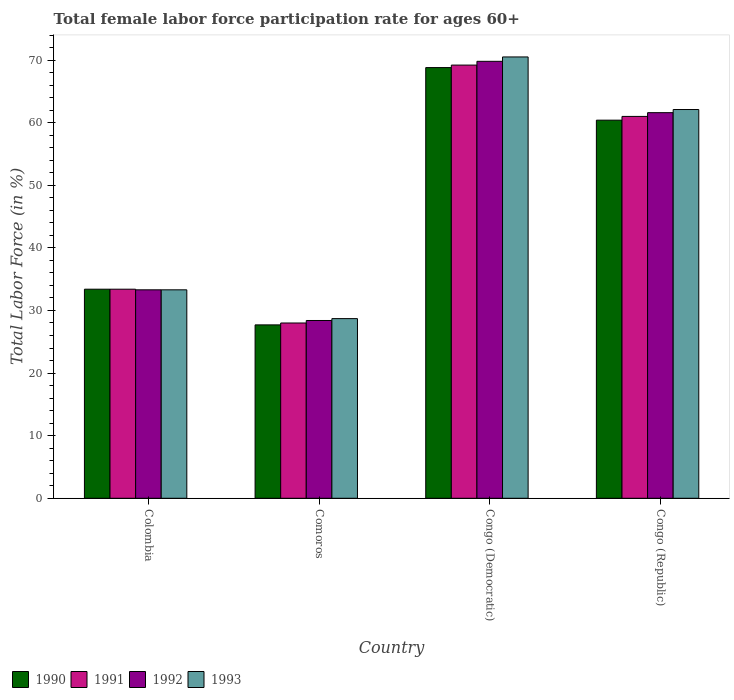Are the number of bars on each tick of the X-axis equal?
Give a very brief answer. Yes. How many bars are there on the 2nd tick from the left?
Provide a short and direct response. 4. What is the label of the 3rd group of bars from the left?
Make the answer very short. Congo (Democratic). In how many cases, is the number of bars for a given country not equal to the number of legend labels?
Your response must be concise. 0. What is the female labor force participation rate in 1990 in Congo (Democratic)?
Offer a terse response. 68.8. Across all countries, what is the maximum female labor force participation rate in 1993?
Give a very brief answer. 70.5. Across all countries, what is the minimum female labor force participation rate in 1993?
Your answer should be very brief. 28.7. In which country was the female labor force participation rate in 1992 maximum?
Your response must be concise. Congo (Democratic). In which country was the female labor force participation rate in 1990 minimum?
Your answer should be very brief. Comoros. What is the total female labor force participation rate in 1992 in the graph?
Provide a short and direct response. 193.1. What is the difference between the female labor force participation rate in 1992 in Colombia and that in Congo (Republic)?
Offer a terse response. -28.3. What is the difference between the female labor force participation rate in 1990 in Comoros and the female labor force participation rate in 1992 in Congo (Republic)?
Your answer should be very brief. -33.9. What is the average female labor force participation rate in 1990 per country?
Your response must be concise. 47.58. What is the difference between the female labor force participation rate of/in 1993 and female labor force participation rate of/in 1991 in Colombia?
Keep it short and to the point. -0.1. What is the ratio of the female labor force participation rate in 1993 in Comoros to that in Congo (Republic)?
Your answer should be compact. 0.46. What is the difference between the highest and the second highest female labor force participation rate in 1993?
Keep it short and to the point. 28.8. What is the difference between the highest and the lowest female labor force participation rate in 1993?
Provide a short and direct response. 41.8. Is the sum of the female labor force participation rate in 1991 in Colombia and Congo (Republic) greater than the maximum female labor force participation rate in 1993 across all countries?
Keep it short and to the point. Yes. Is it the case that in every country, the sum of the female labor force participation rate in 1992 and female labor force participation rate in 1991 is greater than the sum of female labor force participation rate in 1993 and female labor force participation rate in 1990?
Your response must be concise. No. What does the 4th bar from the left in Congo (Republic) represents?
Offer a terse response. 1993. What is the difference between two consecutive major ticks on the Y-axis?
Your response must be concise. 10. Does the graph contain any zero values?
Give a very brief answer. No. Does the graph contain grids?
Your response must be concise. No. Where does the legend appear in the graph?
Your answer should be very brief. Bottom left. How are the legend labels stacked?
Ensure brevity in your answer.  Horizontal. What is the title of the graph?
Offer a very short reply. Total female labor force participation rate for ages 60+. Does "1978" appear as one of the legend labels in the graph?
Provide a succinct answer. No. What is the label or title of the Y-axis?
Ensure brevity in your answer.  Total Labor Force (in %). What is the Total Labor Force (in %) of 1990 in Colombia?
Ensure brevity in your answer.  33.4. What is the Total Labor Force (in %) in 1991 in Colombia?
Give a very brief answer. 33.4. What is the Total Labor Force (in %) in 1992 in Colombia?
Provide a short and direct response. 33.3. What is the Total Labor Force (in %) in 1993 in Colombia?
Keep it short and to the point. 33.3. What is the Total Labor Force (in %) of 1990 in Comoros?
Your answer should be very brief. 27.7. What is the Total Labor Force (in %) in 1992 in Comoros?
Offer a very short reply. 28.4. What is the Total Labor Force (in %) of 1993 in Comoros?
Your answer should be compact. 28.7. What is the Total Labor Force (in %) of 1990 in Congo (Democratic)?
Your answer should be compact. 68.8. What is the Total Labor Force (in %) of 1991 in Congo (Democratic)?
Your answer should be compact. 69.2. What is the Total Labor Force (in %) in 1992 in Congo (Democratic)?
Make the answer very short. 69.8. What is the Total Labor Force (in %) in 1993 in Congo (Democratic)?
Provide a succinct answer. 70.5. What is the Total Labor Force (in %) of 1990 in Congo (Republic)?
Provide a short and direct response. 60.4. What is the Total Labor Force (in %) in 1991 in Congo (Republic)?
Your answer should be very brief. 61. What is the Total Labor Force (in %) in 1992 in Congo (Republic)?
Offer a terse response. 61.6. What is the Total Labor Force (in %) of 1993 in Congo (Republic)?
Provide a succinct answer. 62.1. Across all countries, what is the maximum Total Labor Force (in %) of 1990?
Provide a succinct answer. 68.8. Across all countries, what is the maximum Total Labor Force (in %) of 1991?
Ensure brevity in your answer.  69.2. Across all countries, what is the maximum Total Labor Force (in %) of 1992?
Provide a short and direct response. 69.8. Across all countries, what is the maximum Total Labor Force (in %) in 1993?
Offer a terse response. 70.5. Across all countries, what is the minimum Total Labor Force (in %) of 1990?
Keep it short and to the point. 27.7. Across all countries, what is the minimum Total Labor Force (in %) of 1991?
Keep it short and to the point. 28. Across all countries, what is the minimum Total Labor Force (in %) of 1992?
Your answer should be very brief. 28.4. Across all countries, what is the minimum Total Labor Force (in %) in 1993?
Make the answer very short. 28.7. What is the total Total Labor Force (in %) of 1990 in the graph?
Provide a succinct answer. 190.3. What is the total Total Labor Force (in %) of 1991 in the graph?
Your answer should be very brief. 191.6. What is the total Total Labor Force (in %) of 1992 in the graph?
Your response must be concise. 193.1. What is the total Total Labor Force (in %) in 1993 in the graph?
Ensure brevity in your answer.  194.6. What is the difference between the Total Labor Force (in %) in 1990 in Colombia and that in Congo (Democratic)?
Provide a succinct answer. -35.4. What is the difference between the Total Labor Force (in %) of 1991 in Colombia and that in Congo (Democratic)?
Provide a succinct answer. -35.8. What is the difference between the Total Labor Force (in %) of 1992 in Colombia and that in Congo (Democratic)?
Your answer should be very brief. -36.5. What is the difference between the Total Labor Force (in %) of 1993 in Colombia and that in Congo (Democratic)?
Your answer should be compact. -37.2. What is the difference between the Total Labor Force (in %) in 1991 in Colombia and that in Congo (Republic)?
Ensure brevity in your answer.  -27.6. What is the difference between the Total Labor Force (in %) of 1992 in Colombia and that in Congo (Republic)?
Offer a terse response. -28.3. What is the difference between the Total Labor Force (in %) in 1993 in Colombia and that in Congo (Republic)?
Give a very brief answer. -28.8. What is the difference between the Total Labor Force (in %) of 1990 in Comoros and that in Congo (Democratic)?
Give a very brief answer. -41.1. What is the difference between the Total Labor Force (in %) of 1991 in Comoros and that in Congo (Democratic)?
Your answer should be very brief. -41.2. What is the difference between the Total Labor Force (in %) of 1992 in Comoros and that in Congo (Democratic)?
Your answer should be very brief. -41.4. What is the difference between the Total Labor Force (in %) of 1993 in Comoros and that in Congo (Democratic)?
Give a very brief answer. -41.8. What is the difference between the Total Labor Force (in %) in 1990 in Comoros and that in Congo (Republic)?
Provide a short and direct response. -32.7. What is the difference between the Total Labor Force (in %) of 1991 in Comoros and that in Congo (Republic)?
Ensure brevity in your answer.  -33. What is the difference between the Total Labor Force (in %) in 1992 in Comoros and that in Congo (Republic)?
Make the answer very short. -33.2. What is the difference between the Total Labor Force (in %) in 1993 in Comoros and that in Congo (Republic)?
Your answer should be compact. -33.4. What is the difference between the Total Labor Force (in %) of 1990 in Congo (Democratic) and that in Congo (Republic)?
Give a very brief answer. 8.4. What is the difference between the Total Labor Force (in %) of 1992 in Congo (Democratic) and that in Congo (Republic)?
Provide a succinct answer. 8.2. What is the difference between the Total Labor Force (in %) in 1990 in Colombia and the Total Labor Force (in %) in 1991 in Comoros?
Provide a short and direct response. 5.4. What is the difference between the Total Labor Force (in %) in 1990 in Colombia and the Total Labor Force (in %) in 1992 in Comoros?
Provide a succinct answer. 5. What is the difference between the Total Labor Force (in %) of 1991 in Colombia and the Total Labor Force (in %) of 1993 in Comoros?
Offer a terse response. 4.7. What is the difference between the Total Labor Force (in %) in 1992 in Colombia and the Total Labor Force (in %) in 1993 in Comoros?
Ensure brevity in your answer.  4.6. What is the difference between the Total Labor Force (in %) in 1990 in Colombia and the Total Labor Force (in %) in 1991 in Congo (Democratic)?
Offer a very short reply. -35.8. What is the difference between the Total Labor Force (in %) in 1990 in Colombia and the Total Labor Force (in %) in 1992 in Congo (Democratic)?
Your answer should be very brief. -36.4. What is the difference between the Total Labor Force (in %) in 1990 in Colombia and the Total Labor Force (in %) in 1993 in Congo (Democratic)?
Give a very brief answer. -37.1. What is the difference between the Total Labor Force (in %) of 1991 in Colombia and the Total Labor Force (in %) of 1992 in Congo (Democratic)?
Give a very brief answer. -36.4. What is the difference between the Total Labor Force (in %) in 1991 in Colombia and the Total Labor Force (in %) in 1993 in Congo (Democratic)?
Your response must be concise. -37.1. What is the difference between the Total Labor Force (in %) of 1992 in Colombia and the Total Labor Force (in %) of 1993 in Congo (Democratic)?
Offer a terse response. -37.2. What is the difference between the Total Labor Force (in %) in 1990 in Colombia and the Total Labor Force (in %) in 1991 in Congo (Republic)?
Give a very brief answer. -27.6. What is the difference between the Total Labor Force (in %) of 1990 in Colombia and the Total Labor Force (in %) of 1992 in Congo (Republic)?
Your answer should be very brief. -28.2. What is the difference between the Total Labor Force (in %) of 1990 in Colombia and the Total Labor Force (in %) of 1993 in Congo (Republic)?
Make the answer very short. -28.7. What is the difference between the Total Labor Force (in %) of 1991 in Colombia and the Total Labor Force (in %) of 1992 in Congo (Republic)?
Give a very brief answer. -28.2. What is the difference between the Total Labor Force (in %) in 1991 in Colombia and the Total Labor Force (in %) in 1993 in Congo (Republic)?
Make the answer very short. -28.7. What is the difference between the Total Labor Force (in %) in 1992 in Colombia and the Total Labor Force (in %) in 1993 in Congo (Republic)?
Offer a terse response. -28.8. What is the difference between the Total Labor Force (in %) of 1990 in Comoros and the Total Labor Force (in %) of 1991 in Congo (Democratic)?
Your response must be concise. -41.5. What is the difference between the Total Labor Force (in %) in 1990 in Comoros and the Total Labor Force (in %) in 1992 in Congo (Democratic)?
Your answer should be compact. -42.1. What is the difference between the Total Labor Force (in %) in 1990 in Comoros and the Total Labor Force (in %) in 1993 in Congo (Democratic)?
Offer a terse response. -42.8. What is the difference between the Total Labor Force (in %) in 1991 in Comoros and the Total Labor Force (in %) in 1992 in Congo (Democratic)?
Offer a very short reply. -41.8. What is the difference between the Total Labor Force (in %) of 1991 in Comoros and the Total Labor Force (in %) of 1993 in Congo (Democratic)?
Give a very brief answer. -42.5. What is the difference between the Total Labor Force (in %) of 1992 in Comoros and the Total Labor Force (in %) of 1993 in Congo (Democratic)?
Provide a succinct answer. -42.1. What is the difference between the Total Labor Force (in %) in 1990 in Comoros and the Total Labor Force (in %) in 1991 in Congo (Republic)?
Keep it short and to the point. -33.3. What is the difference between the Total Labor Force (in %) of 1990 in Comoros and the Total Labor Force (in %) of 1992 in Congo (Republic)?
Offer a very short reply. -33.9. What is the difference between the Total Labor Force (in %) of 1990 in Comoros and the Total Labor Force (in %) of 1993 in Congo (Republic)?
Keep it short and to the point. -34.4. What is the difference between the Total Labor Force (in %) of 1991 in Comoros and the Total Labor Force (in %) of 1992 in Congo (Republic)?
Provide a succinct answer. -33.6. What is the difference between the Total Labor Force (in %) of 1991 in Comoros and the Total Labor Force (in %) of 1993 in Congo (Republic)?
Your response must be concise. -34.1. What is the difference between the Total Labor Force (in %) in 1992 in Comoros and the Total Labor Force (in %) in 1993 in Congo (Republic)?
Your answer should be very brief. -33.7. What is the difference between the Total Labor Force (in %) in 1990 in Congo (Democratic) and the Total Labor Force (in %) in 1993 in Congo (Republic)?
Provide a short and direct response. 6.7. What is the difference between the Total Labor Force (in %) in 1991 in Congo (Democratic) and the Total Labor Force (in %) in 1992 in Congo (Republic)?
Make the answer very short. 7.6. What is the difference between the Total Labor Force (in %) of 1991 in Congo (Democratic) and the Total Labor Force (in %) of 1993 in Congo (Republic)?
Provide a succinct answer. 7.1. What is the average Total Labor Force (in %) in 1990 per country?
Your answer should be very brief. 47.58. What is the average Total Labor Force (in %) in 1991 per country?
Ensure brevity in your answer.  47.9. What is the average Total Labor Force (in %) in 1992 per country?
Offer a very short reply. 48.27. What is the average Total Labor Force (in %) of 1993 per country?
Offer a terse response. 48.65. What is the difference between the Total Labor Force (in %) in 1990 and Total Labor Force (in %) in 1991 in Colombia?
Offer a terse response. 0. What is the difference between the Total Labor Force (in %) of 1990 and Total Labor Force (in %) of 1992 in Colombia?
Offer a terse response. 0.1. What is the difference between the Total Labor Force (in %) of 1990 and Total Labor Force (in %) of 1993 in Colombia?
Make the answer very short. 0.1. What is the difference between the Total Labor Force (in %) in 1991 and Total Labor Force (in %) in 1993 in Colombia?
Your response must be concise. 0.1. What is the difference between the Total Labor Force (in %) of 1990 and Total Labor Force (in %) of 1992 in Comoros?
Your answer should be compact. -0.7. What is the difference between the Total Labor Force (in %) of 1991 and Total Labor Force (in %) of 1992 in Comoros?
Your response must be concise. -0.4. What is the difference between the Total Labor Force (in %) in 1991 and Total Labor Force (in %) in 1993 in Comoros?
Ensure brevity in your answer.  -0.7. What is the difference between the Total Labor Force (in %) in 1990 and Total Labor Force (in %) in 1991 in Congo (Democratic)?
Ensure brevity in your answer.  -0.4. What is the difference between the Total Labor Force (in %) in 1990 and Total Labor Force (in %) in 1993 in Congo (Democratic)?
Your answer should be very brief. -1.7. What is the difference between the Total Labor Force (in %) of 1991 and Total Labor Force (in %) of 1993 in Congo (Democratic)?
Give a very brief answer. -1.3. What is the difference between the Total Labor Force (in %) of 1992 and Total Labor Force (in %) of 1993 in Congo (Democratic)?
Provide a succinct answer. -0.7. What is the difference between the Total Labor Force (in %) in 1990 and Total Labor Force (in %) in 1991 in Congo (Republic)?
Your answer should be compact. -0.6. What is the difference between the Total Labor Force (in %) of 1990 and Total Labor Force (in %) of 1992 in Congo (Republic)?
Offer a terse response. -1.2. What is the difference between the Total Labor Force (in %) of 1990 and Total Labor Force (in %) of 1993 in Congo (Republic)?
Offer a terse response. -1.7. What is the ratio of the Total Labor Force (in %) in 1990 in Colombia to that in Comoros?
Your response must be concise. 1.21. What is the ratio of the Total Labor Force (in %) of 1991 in Colombia to that in Comoros?
Provide a succinct answer. 1.19. What is the ratio of the Total Labor Force (in %) of 1992 in Colombia to that in Comoros?
Make the answer very short. 1.17. What is the ratio of the Total Labor Force (in %) in 1993 in Colombia to that in Comoros?
Your answer should be compact. 1.16. What is the ratio of the Total Labor Force (in %) of 1990 in Colombia to that in Congo (Democratic)?
Your answer should be very brief. 0.49. What is the ratio of the Total Labor Force (in %) of 1991 in Colombia to that in Congo (Democratic)?
Your answer should be very brief. 0.48. What is the ratio of the Total Labor Force (in %) of 1992 in Colombia to that in Congo (Democratic)?
Give a very brief answer. 0.48. What is the ratio of the Total Labor Force (in %) of 1993 in Colombia to that in Congo (Democratic)?
Ensure brevity in your answer.  0.47. What is the ratio of the Total Labor Force (in %) in 1990 in Colombia to that in Congo (Republic)?
Your response must be concise. 0.55. What is the ratio of the Total Labor Force (in %) of 1991 in Colombia to that in Congo (Republic)?
Your answer should be compact. 0.55. What is the ratio of the Total Labor Force (in %) of 1992 in Colombia to that in Congo (Republic)?
Keep it short and to the point. 0.54. What is the ratio of the Total Labor Force (in %) of 1993 in Colombia to that in Congo (Republic)?
Provide a short and direct response. 0.54. What is the ratio of the Total Labor Force (in %) of 1990 in Comoros to that in Congo (Democratic)?
Provide a succinct answer. 0.4. What is the ratio of the Total Labor Force (in %) in 1991 in Comoros to that in Congo (Democratic)?
Your answer should be compact. 0.4. What is the ratio of the Total Labor Force (in %) of 1992 in Comoros to that in Congo (Democratic)?
Provide a short and direct response. 0.41. What is the ratio of the Total Labor Force (in %) of 1993 in Comoros to that in Congo (Democratic)?
Offer a terse response. 0.41. What is the ratio of the Total Labor Force (in %) in 1990 in Comoros to that in Congo (Republic)?
Offer a very short reply. 0.46. What is the ratio of the Total Labor Force (in %) in 1991 in Comoros to that in Congo (Republic)?
Provide a short and direct response. 0.46. What is the ratio of the Total Labor Force (in %) in 1992 in Comoros to that in Congo (Republic)?
Make the answer very short. 0.46. What is the ratio of the Total Labor Force (in %) of 1993 in Comoros to that in Congo (Republic)?
Give a very brief answer. 0.46. What is the ratio of the Total Labor Force (in %) in 1990 in Congo (Democratic) to that in Congo (Republic)?
Your answer should be very brief. 1.14. What is the ratio of the Total Labor Force (in %) of 1991 in Congo (Democratic) to that in Congo (Republic)?
Give a very brief answer. 1.13. What is the ratio of the Total Labor Force (in %) of 1992 in Congo (Democratic) to that in Congo (Republic)?
Provide a succinct answer. 1.13. What is the ratio of the Total Labor Force (in %) in 1993 in Congo (Democratic) to that in Congo (Republic)?
Offer a very short reply. 1.14. What is the difference between the highest and the second highest Total Labor Force (in %) in 1990?
Make the answer very short. 8.4. What is the difference between the highest and the second highest Total Labor Force (in %) in 1991?
Offer a very short reply. 8.2. What is the difference between the highest and the second highest Total Labor Force (in %) of 1992?
Keep it short and to the point. 8.2. What is the difference between the highest and the lowest Total Labor Force (in %) in 1990?
Your response must be concise. 41.1. What is the difference between the highest and the lowest Total Labor Force (in %) in 1991?
Your answer should be very brief. 41.2. What is the difference between the highest and the lowest Total Labor Force (in %) of 1992?
Your answer should be compact. 41.4. What is the difference between the highest and the lowest Total Labor Force (in %) in 1993?
Your answer should be compact. 41.8. 